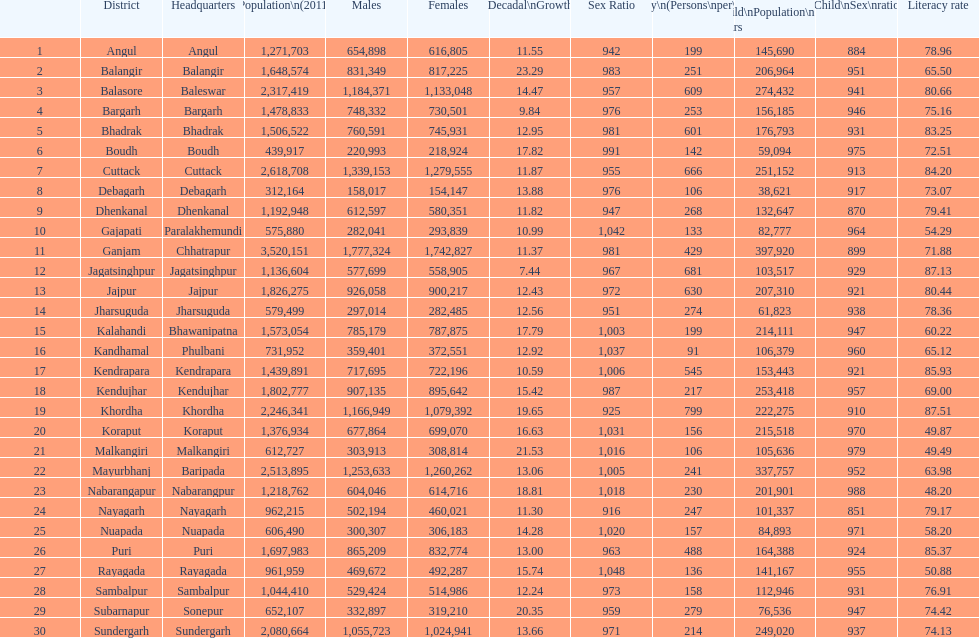Would you be able to parse every entry in this table? {'header': ['', 'District', 'Headquarters', 'Population\\n(2011)', 'Males', 'Females', 'Percentage\\nDecadal\\nGrowth\\n2001-2011', 'Sex Ratio', 'Density\\n(Persons\\nper\\nkm2)', 'Child\\nPopulation\\n0–6 years', 'Child\\nSex\\nratio', 'Literacy rate'], 'rows': [['1', 'Angul', 'Angul', '1,271,703', '654,898', '616,805', '11.55', '942', '199', '145,690', '884', '78.96'], ['2', 'Balangir', 'Balangir', '1,648,574', '831,349', '817,225', '23.29', '983', '251', '206,964', '951', '65.50'], ['3', 'Balasore', 'Baleswar', '2,317,419', '1,184,371', '1,133,048', '14.47', '957', '609', '274,432', '941', '80.66'], ['4', 'Bargarh', 'Bargarh', '1,478,833', '748,332', '730,501', '9.84', '976', '253', '156,185', '946', '75.16'], ['5', 'Bhadrak', 'Bhadrak', '1,506,522', '760,591', '745,931', '12.95', '981', '601', '176,793', '931', '83.25'], ['6', 'Boudh', 'Boudh', '439,917', '220,993', '218,924', '17.82', '991', '142', '59,094', '975', '72.51'], ['7', 'Cuttack', 'Cuttack', '2,618,708', '1,339,153', '1,279,555', '11.87', '955', '666', '251,152', '913', '84.20'], ['8', 'Debagarh', 'Debagarh', '312,164', '158,017', '154,147', '13.88', '976', '106', '38,621', '917', '73.07'], ['9', 'Dhenkanal', 'Dhenkanal', '1,192,948', '612,597', '580,351', '11.82', '947', '268', '132,647', '870', '79.41'], ['10', 'Gajapati', 'Paralakhemundi', '575,880', '282,041', '293,839', '10.99', '1,042', '133', '82,777', '964', '54.29'], ['11', 'Ganjam', 'Chhatrapur', '3,520,151', '1,777,324', '1,742,827', '11.37', '981', '429', '397,920', '899', '71.88'], ['12', 'Jagatsinghpur', 'Jagatsinghpur', '1,136,604', '577,699', '558,905', '7.44', '967', '681', '103,517', '929', '87.13'], ['13', 'Jajpur', 'Jajpur', '1,826,275', '926,058', '900,217', '12.43', '972', '630', '207,310', '921', '80.44'], ['14', 'Jharsuguda', 'Jharsuguda', '579,499', '297,014', '282,485', '12.56', '951', '274', '61,823', '938', '78.36'], ['15', 'Kalahandi', 'Bhawanipatna', '1,573,054', '785,179', '787,875', '17.79', '1,003', '199', '214,111', '947', '60.22'], ['16', 'Kandhamal', 'Phulbani', '731,952', '359,401', '372,551', '12.92', '1,037', '91', '106,379', '960', '65.12'], ['17', 'Kendrapara', 'Kendrapara', '1,439,891', '717,695', '722,196', '10.59', '1,006', '545', '153,443', '921', '85.93'], ['18', 'Kendujhar', 'Kendujhar', '1,802,777', '907,135', '895,642', '15.42', '987', '217', '253,418', '957', '69.00'], ['19', 'Khordha', 'Khordha', '2,246,341', '1,166,949', '1,079,392', '19.65', '925', '799', '222,275', '910', '87.51'], ['20', 'Koraput', 'Koraput', '1,376,934', '677,864', '699,070', '16.63', '1,031', '156', '215,518', '970', '49.87'], ['21', 'Malkangiri', 'Malkangiri', '612,727', '303,913', '308,814', '21.53', '1,016', '106', '105,636', '979', '49.49'], ['22', 'Mayurbhanj', 'Baripada', '2,513,895', '1,253,633', '1,260,262', '13.06', '1,005', '241', '337,757', '952', '63.98'], ['23', 'Nabarangapur', 'Nabarangpur', '1,218,762', '604,046', '614,716', '18.81', '1,018', '230', '201,901', '988', '48.20'], ['24', 'Nayagarh', 'Nayagarh', '962,215', '502,194', '460,021', '11.30', '916', '247', '101,337', '851', '79.17'], ['25', 'Nuapada', 'Nuapada', '606,490', '300,307', '306,183', '14.28', '1,020', '157', '84,893', '971', '58.20'], ['26', 'Puri', 'Puri', '1,697,983', '865,209', '832,774', '13.00', '963', '488', '164,388', '924', '85.37'], ['27', 'Rayagada', 'Rayagada', '961,959', '469,672', '492,287', '15.74', '1,048', '136', '141,167', '955', '50.88'], ['28', 'Sambalpur', 'Sambalpur', '1,044,410', '529,424', '514,986', '12.24', '973', '158', '112,946', '931', '76.91'], ['29', 'Subarnapur', 'Sonepur', '652,107', '332,897', '319,210', '20.35', '959', '279', '76,536', '947', '74.42'], ['30', 'Sundergarh', 'Sundergarh', '2,080,664', '1,055,723', '1,024,941', '13.66', '971', '214', '249,020', '937', '74.13']]} How many females live in cuttack? 1,279,555. 